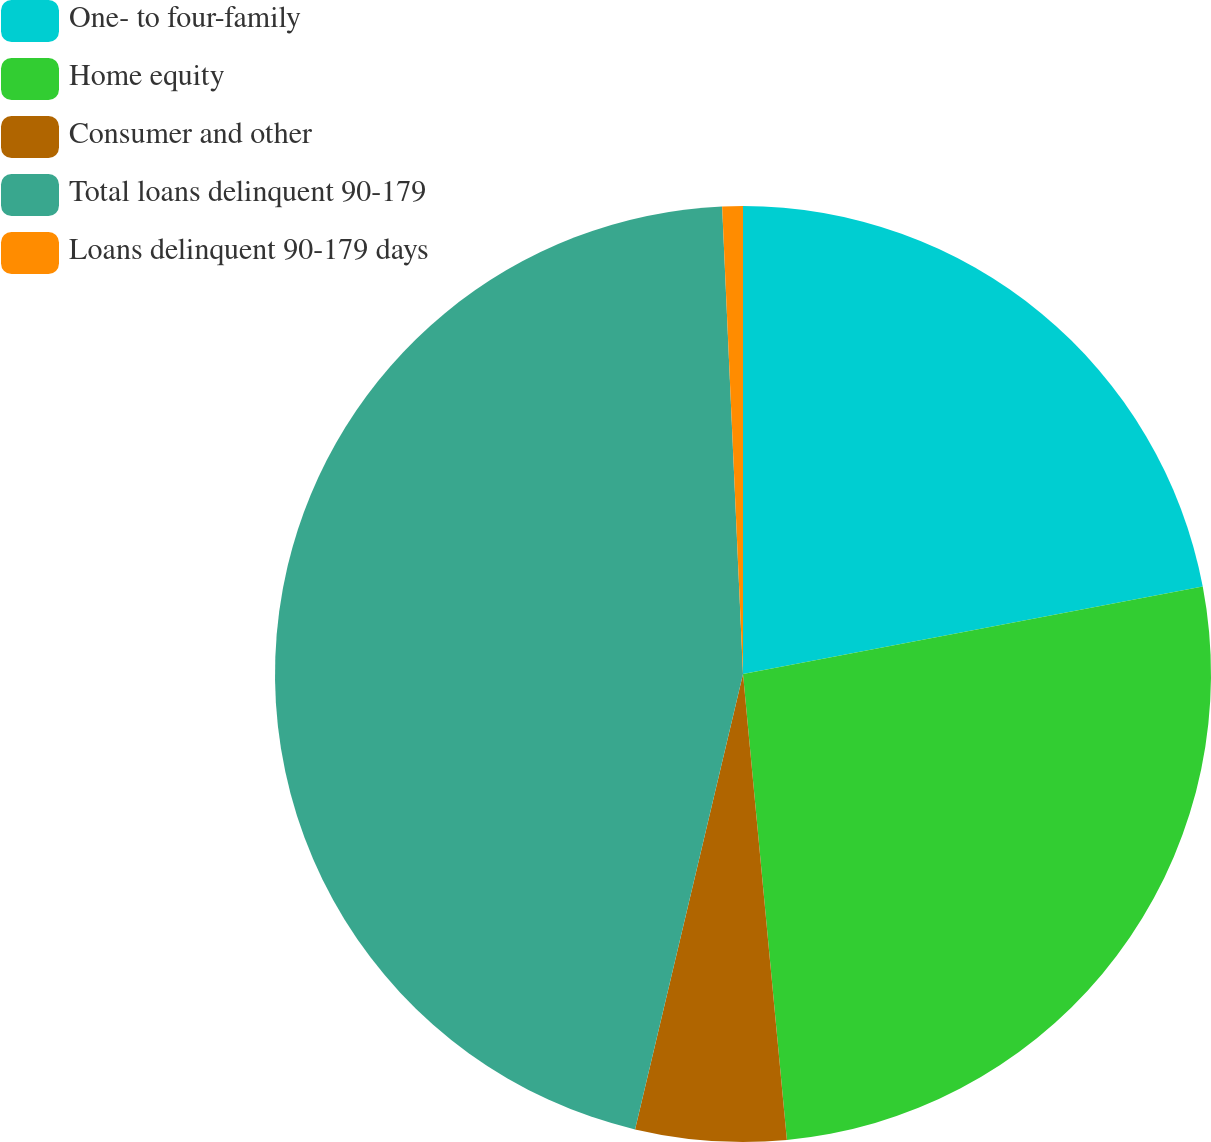Convert chart. <chart><loc_0><loc_0><loc_500><loc_500><pie_chart><fcel>One- to four-family<fcel>Home equity<fcel>Consumer and other<fcel>Total loans delinquent 90-179<fcel>Loans delinquent 90-179 days<nl><fcel>22.01%<fcel>26.5%<fcel>5.2%<fcel>45.59%<fcel>0.71%<nl></chart> 